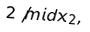<formula> <loc_0><loc_0><loc_500><loc_500>2 \not m i d x _ { 2 } ,</formula> 